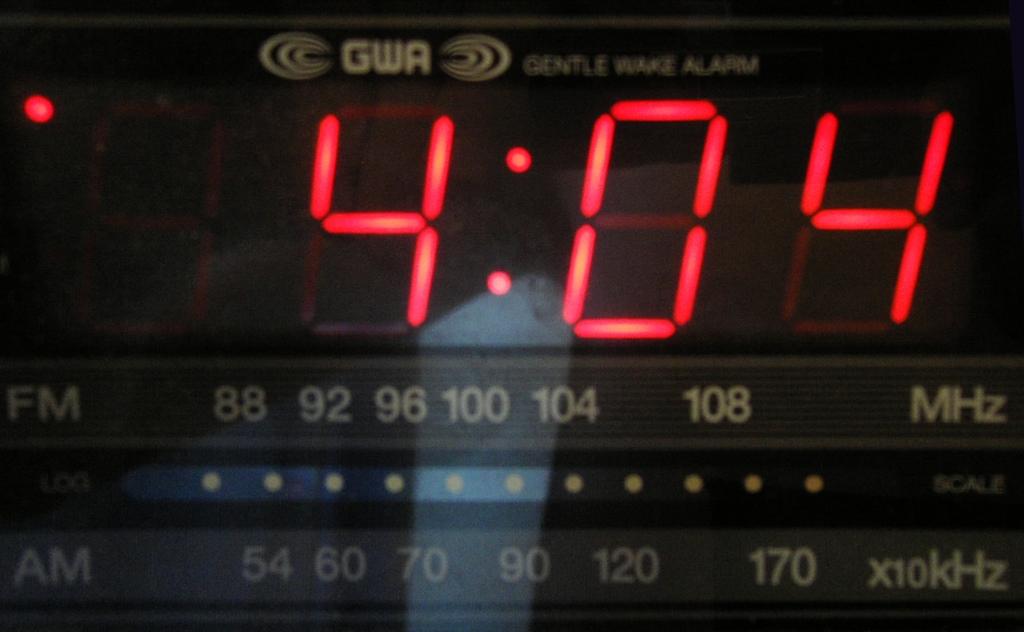What kind of alarm is it?
Give a very brief answer. Gentle wake. 